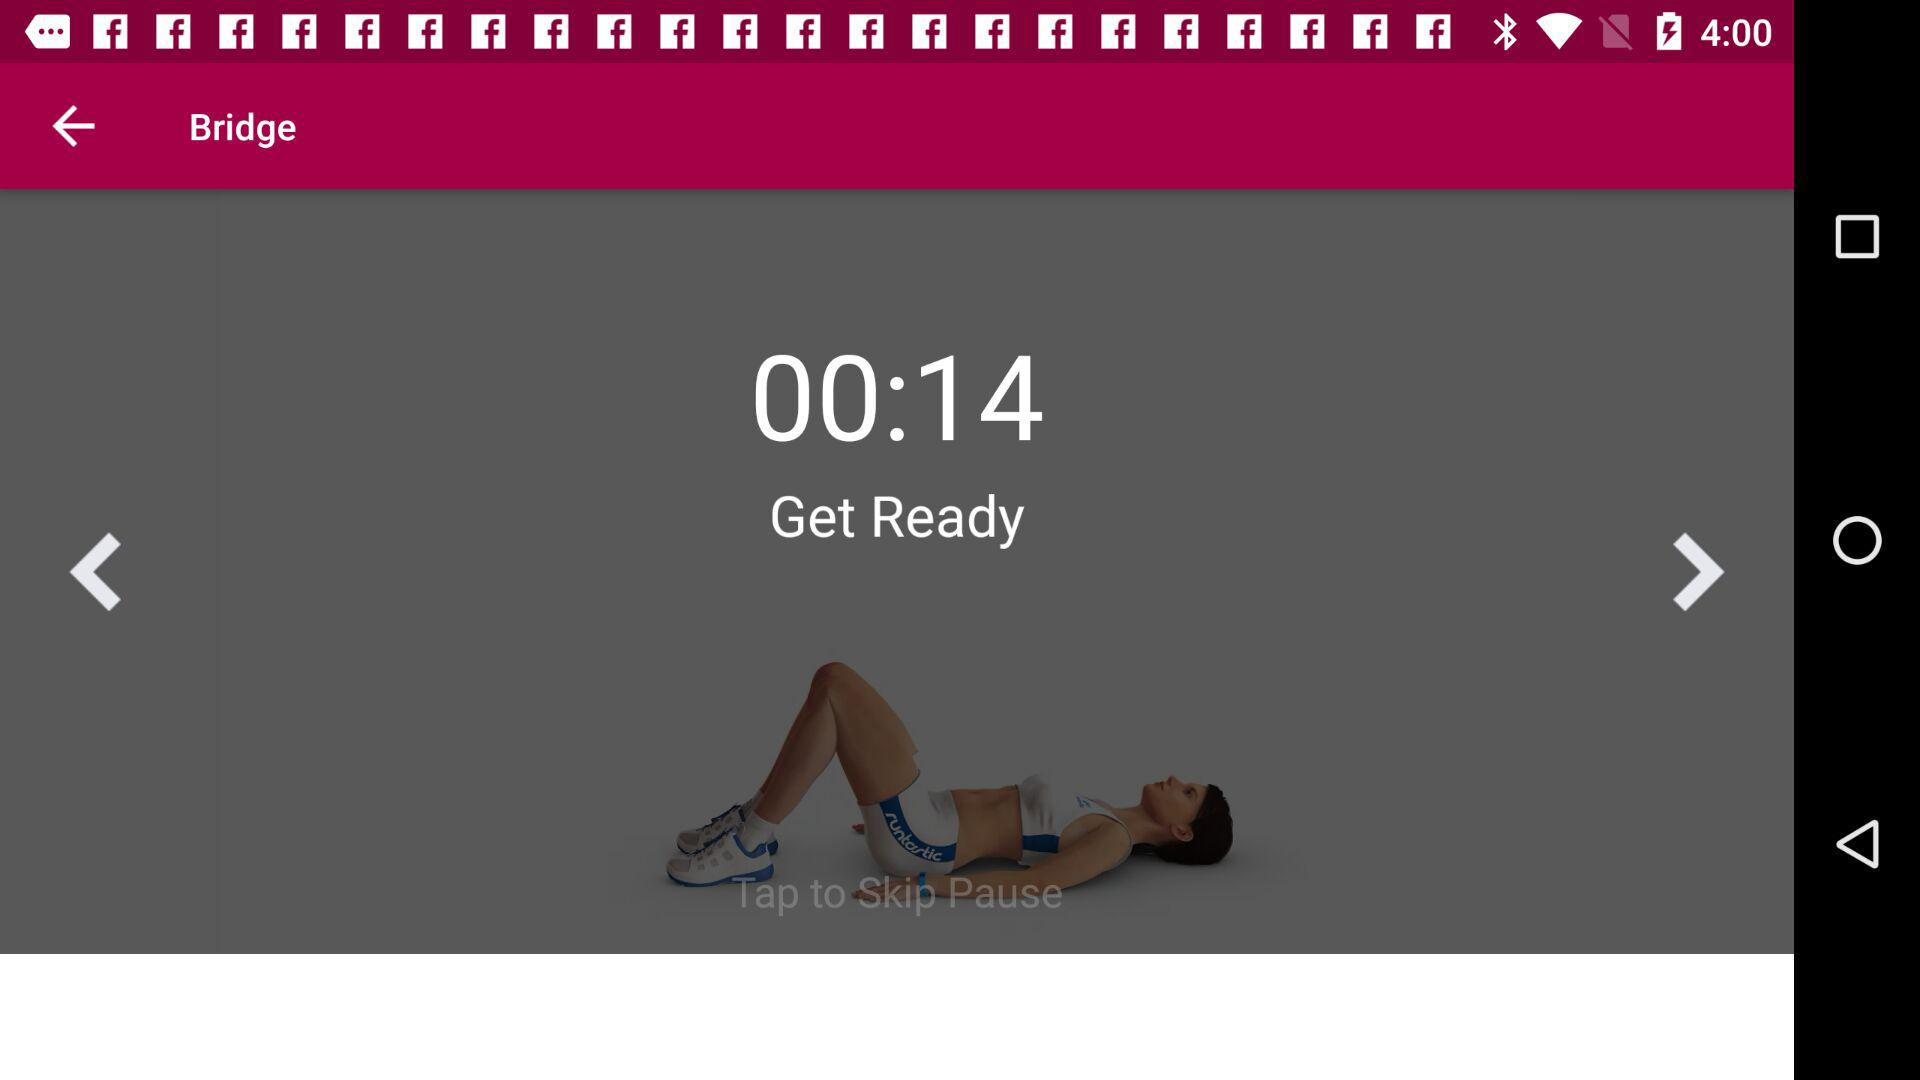What is the application name? The application name is "runtastic Butt Trainer". 